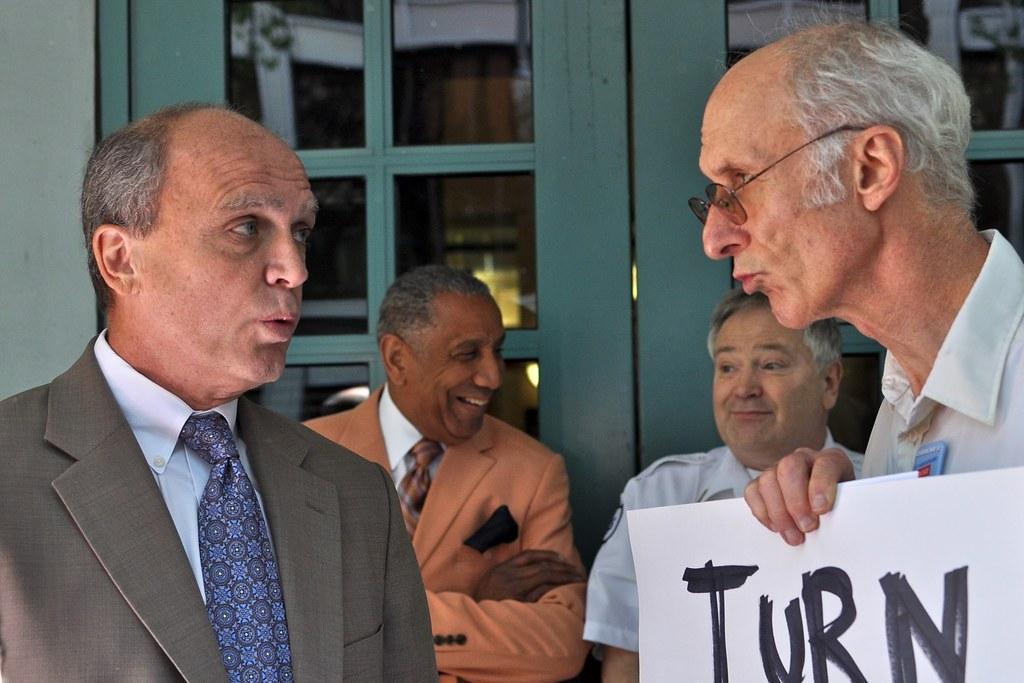How would you summarize this image in a sentence or two? In this image in the front there are persons standing and having expression on their faces. On the right side there is a person standing and holding banner with some text written on it. In the center there are persons standing and smiling. In the background there is a door and behind the door there are objects. On the left side of the door there is a wall. 